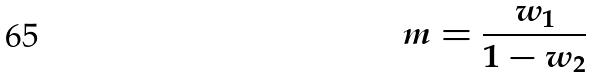<formula> <loc_0><loc_0><loc_500><loc_500>m = \frac { w _ { 1 } } { 1 - w _ { 2 } }</formula> 